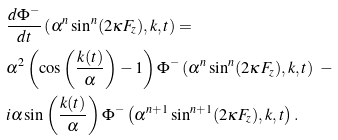<formula> <loc_0><loc_0><loc_500><loc_500>& \frac { d \Phi ^ { - } } { d t } \left ( \alpha ^ { n } \sin ^ { n } ( 2 \kappa F _ { z } ) , k , t \right ) = \\ & \alpha ^ { 2 } \left ( \cos \left ( \frac { k ( t ) } { \alpha } \right ) - 1 \right ) \Phi ^ { - } \left ( \alpha ^ { n } \sin ^ { n } ( 2 \kappa F _ { z } ) , k , t \right ) \ - \\ & i \alpha \sin \left ( \frac { k ( t ) } { \alpha } \right ) \Phi ^ { - } \left ( \alpha ^ { n + 1 } \sin ^ { n + 1 } ( 2 \kappa F _ { z } ) , k , t \right ) .</formula> 